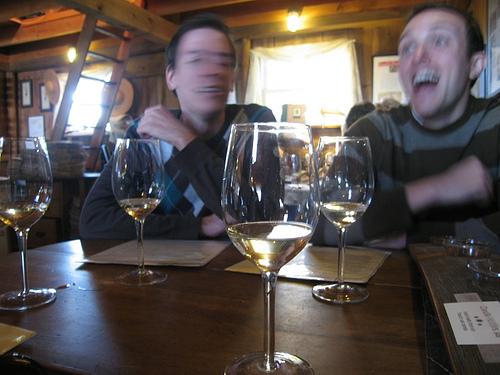What emotion is the person on the right showing?
Write a very short answer. Happy. Is the image blurry?
Concise answer only. Yes. What kind of wine are they drinking?
Keep it brief. White. 